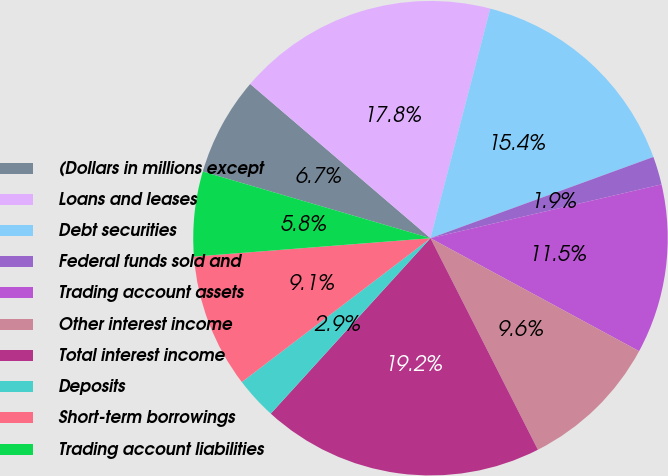Convert chart. <chart><loc_0><loc_0><loc_500><loc_500><pie_chart><fcel>(Dollars in millions except<fcel>Loans and leases<fcel>Debt securities<fcel>Federal funds sold and<fcel>Trading account assets<fcel>Other interest income<fcel>Total interest income<fcel>Deposits<fcel>Short-term borrowings<fcel>Trading account liabilities<nl><fcel>6.73%<fcel>17.79%<fcel>15.38%<fcel>1.92%<fcel>11.54%<fcel>9.62%<fcel>19.23%<fcel>2.88%<fcel>9.13%<fcel>5.77%<nl></chart> 